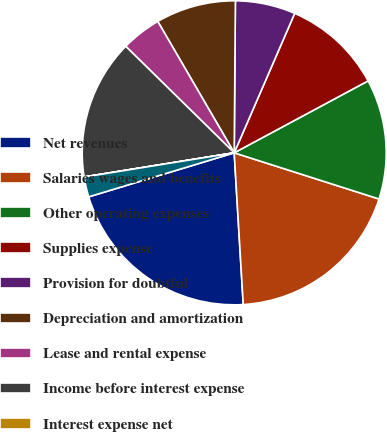<chart> <loc_0><loc_0><loc_500><loc_500><pie_chart><fcel>Net revenues<fcel>Salaries wages and benefits<fcel>Other operating expenses<fcel>Supplies expense<fcel>Provision for doubtful<fcel>Depreciation and amortization<fcel>Lease and rental expense<fcel>Income before interest expense<fcel>Interest expense net<fcel>Minority interests in earnings<nl><fcel>21.27%<fcel>19.14%<fcel>12.76%<fcel>10.64%<fcel>6.39%<fcel>8.51%<fcel>4.26%<fcel>14.89%<fcel>0.01%<fcel>2.13%<nl></chart> 